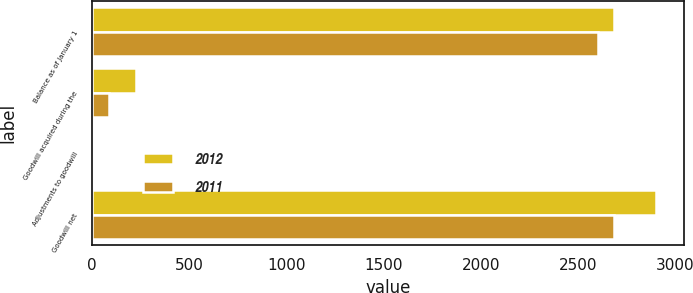<chart> <loc_0><loc_0><loc_500><loc_500><stacked_bar_chart><ecel><fcel>Balance as of January 1<fcel>Goodwill acquired during the<fcel>Adjustments to goodwill<fcel>Goodwill net<nl><fcel>2012<fcel>2681.8<fcel>224.5<fcel>4.6<fcel>2901.7<nl><fcel>2011<fcel>2601.3<fcel>86.2<fcel>5.7<fcel>2681.8<nl></chart> 